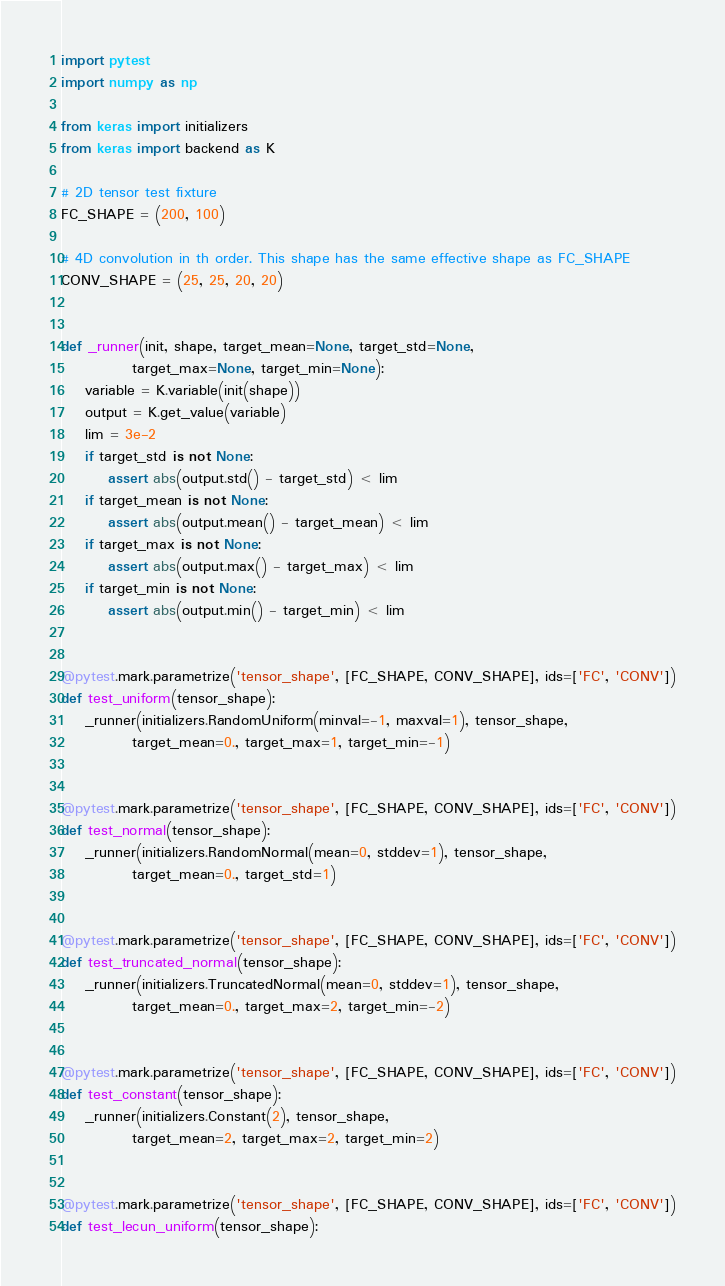Convert code to text. <code><loc_0><loc_0><loc_500><loc_500><_Python_>import pytest
import numpy as np

from keras import initializers
from keras import backend as K

# 2D tensor test fixture
FC_SHAPE = (200, 100)

# 4D convolution in th order. This shape has the same effective shape as FC_SHAPE
CONV_SHAPE = (25, 25, 20, 20)


def _runner(init, shape, target_mean=None, target_std=None,
            target_max=None, target_min=None):
    variable = K.variable(init(shape))
    output = K.get_value(variable)
    lim = 3e-2
    if target_std is not None:
        assert abs(output.std() - target_std) < lim
    if target_mean is not None:
        assert abs(output.mean() - target_mean) < lim
    if target_max is not None:
        assert abs(output.max() - target_max) < lim
    if target_min is not None:
        assert abs(output.min() - target_min) < lim


@pytest.mark.parametrize('tensor_shape', [FC_SHAPE, CONV_SHAPE], ids=['FC', 'CONV'])
def test_uniform(tensor_shape):
    _runner(initializers.RandomUniform(minval=-1, maxval=1), tensor_shape,
            target_mean=0., target_max=1, target_min=-1)


@pytest.mark.parametrize('tensor_shape', [FC_SHAPE, CONV_SHAPE], ids=['FC', 'CONV'])
def test_normal(tensor_shape):
    _runner(initializers.RandomNormal(mean=0, stddev=1), tensor_shape,
            target_mean=0., target_std=1)


@pytest.mark.parametrize('tensor_shape', [FC_SHAPE, CONV_SHAPE], ids=['FC', 'CONV'])
def test_truncated_normal(tensor_shape):
    _runner(initializers.TruncatedNormal(mean=0, stddev=1), tensor_shape,
            target_mean=0., target_max=2, target_min=-2)


@pytest.mark.parametrize('tensor_shape', [FC_SHAPE, CONV_SHAPE], ids=['FC', 'CONV'])
def test_constant(tensor_shape):
    _runner(initializers.Constant(2), tensor_shape,
            target_mean=2, target_max=2, target_min=2)


@pytest.mark.parametrize('tensor_shape', [FC_SHAPE, CONV_SHAPE], ids=['FC', 'CONV'])
def test_lecun_uniform(tensor_shape):</code> 